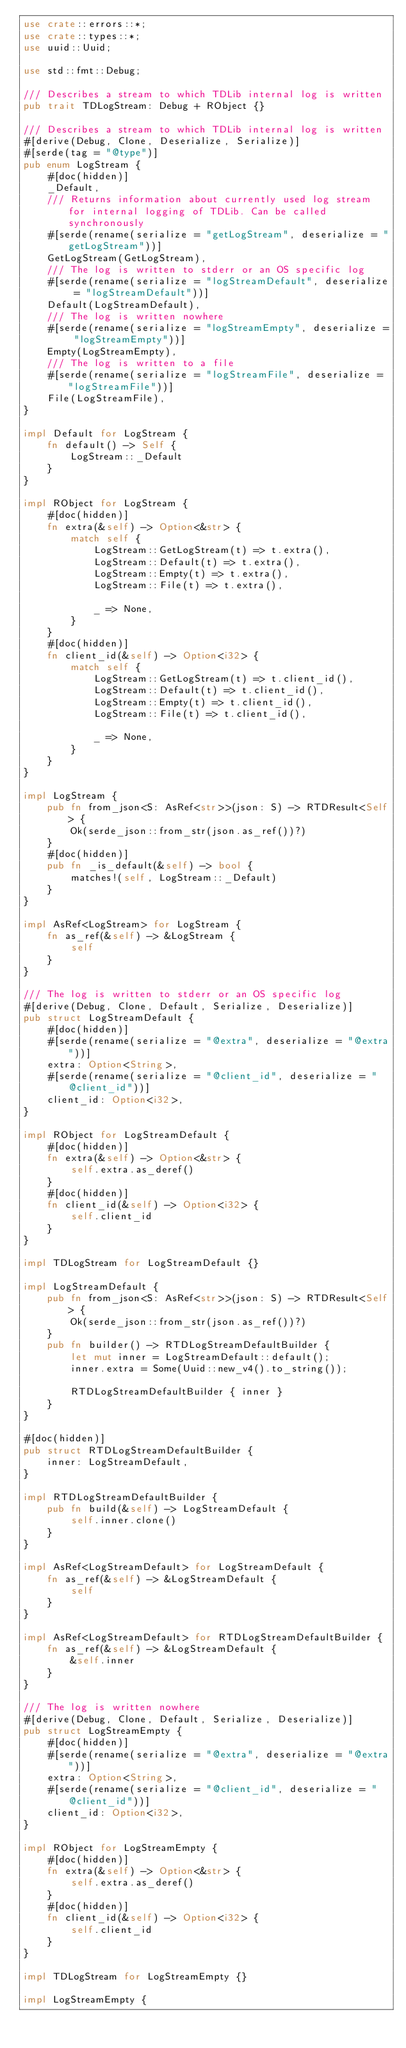Convert code to text. <code><loc_0><loc_0><loc_500><loc_500><_Rust_>use crate::errors::*;
use crate::types::*;
use uuid::Uuid;

use std::fmt::Debug;

/// Describes a stream to which TDLib internal log is written
pub trait TDLogStream: Debug + RObject {}

/// Describes a stream to which TDLib internal log is written
#[derive(Debug, Clone, Deserialize, Serialize)]
#[serde(tag = "@type")]
pub enum LogStream {
    #[doc(hidden)]
    _Default,
    /// Returns information about currently used log stream for internal logging of TDLib. Can be called synchronously
    #[serde(rename(serialize = "getLogStream", deserialize = "getLogStream"))]
    GetLogStream(GetLogStream),
    /// The log is written to stderr or an OS specific log
    #[serde(rename(serialize = "logStreamDefault", deserialize = "logStreamDefault"))]
    Default(LogStreamDefault),
    /// The log is written nowhere
    #[serde(rename(serialize = "logStreamEmpty", deserialize = "logStreamEmpty"))]
    Empty(LogStreamEmpty),
    /// The log is written to a file
    #[serde(rename(serialize = "logStreamFile", deserialize = "logStreamFile"))]
    File(LogStreamFile),
}

impl Default for LogStream {
    fn default() -> Self {
        LogStream::_Default
    }
}

impl RObject for LogStream {
    #[doc(hidden)]
    fn extra(&self) -> Option<&str> {
        match self {
            LogStream::GetLogStream(t) => t.extra(),
            LogStream::Default(t) => t.extra(),
            LogStream::Empty(t) => t.extra(),
            LogStream::File(t) => t.extra(),

            _ => None,
        }
    }
    #[doc(hidden)]
    fn client_id(&self) -> Option<i32> {
        match self {
            LogStream::GetLogStream(t) => t.client_id(),
            LogStream::Default(t) => t.client_id(),
            LogStream::Empty(t) => t.client_id(),
            LogStream::File(t) => t.client_id(),

            _ => None,
        }
    }
}

impl LogStream {
    pub fn from_json<S: AsRef<str>>(json: S) -> RTDResult<Self> {
        Ok(serde_json::from_str(json.as_ref())?)
    }
    #[doc(hidden)]
    pub fn _is_default(&self) -> bool {
        matches!(self, LogStream::_Default)
    }
}

impl AsRef<LogStream> for LogStream {
    fn as_ref(&self) -> &LogStream {
        self
    }
}

/// The log is written to stderr or an OS specific log
#[derive(Debug, Clone, Default, Serialize, Deserialize)]
pub struct LogStreamDefault {
    #[doc(hidden)]
    #[serde(rename(serialize = "@extra", deserialize = "@extra"))]
    extra: Option<String>,
    #[serde(rename(serialize = "@client_id", deserialize = "@client_id"))]
    client_id: Option<i32>,
}

impl RObject for LogStreamDefault {
    #[doc(hidden)]
    fn extra(&self) -> Option<&str> {
        self.extra.as_deref()
    }
    #[doc(hidden)]
    fn client_id(&self) -> Option<i32> {
        self.client_id
    }
}

impl TDLogStream for LogStreamDefault {}

impl LogStreamDefault {
    pub fn from_json<S: AsRef<str>>(json: S) -> RTDResult<Self> {
        Ok(serde_json::from_str(json.as_ref())?)
    }
    pub fn builder() -> RTDLogStreamDefaultBuilder {
        let mut inner = LogStreamDefault::default();
        inner.extra = Some(Uuid::new_v4().to_string());

        RTDLogStreamDefaultBuilder { inner }
    }
}

#[doc(hidden)]
pub struct RTDLogStreamDefaultBuilder {
    inner: LogStreamDefault,
}

impl RTDLogStreamDefaultBuilder {
    pub fn build(&self) -> LogStreamDefault {
        self.inner.clone()
    }
}

impl AsRef<LogStreamDefault> for LogStreamDefault {
    fn as_ref(&self) -> &LogStreamDefault {
        self
    }
}

impl AsRef<LogStreamDefault> for RTDLogStreamDefaultBuilder {
    fn as_ref(&self) -> &LogStreamDefault {
        &self.inner
    }
}

/// The log is written nowhere
#[derive(Debug, Clone, Default, Serialize, Deserialize)]
pub struct LogStreamEmpty {
    #[doc(hidden)]
    #[serde(rename(serialize = "@extra", deserialize = "@extra"))]
    extra: Option<String>,
    #[serde(rename(serialize = "@client_id", deserialize = "@client_id"))]
    client_id: Option<i32>,
}

impl RObject for LogStreamEmpty {
    #[doc(hidden)]
    fn extra(&self) -> Option<&str> {
        self.extra.as_deref()
    }
    #[doc(hidden)]
    fn client_id(&self) -> Option<i32> {
        self.client_id
    }
}

impl TDLogStream for LogStreamEmpty {}

impl LogStreamEmpty {</code> 